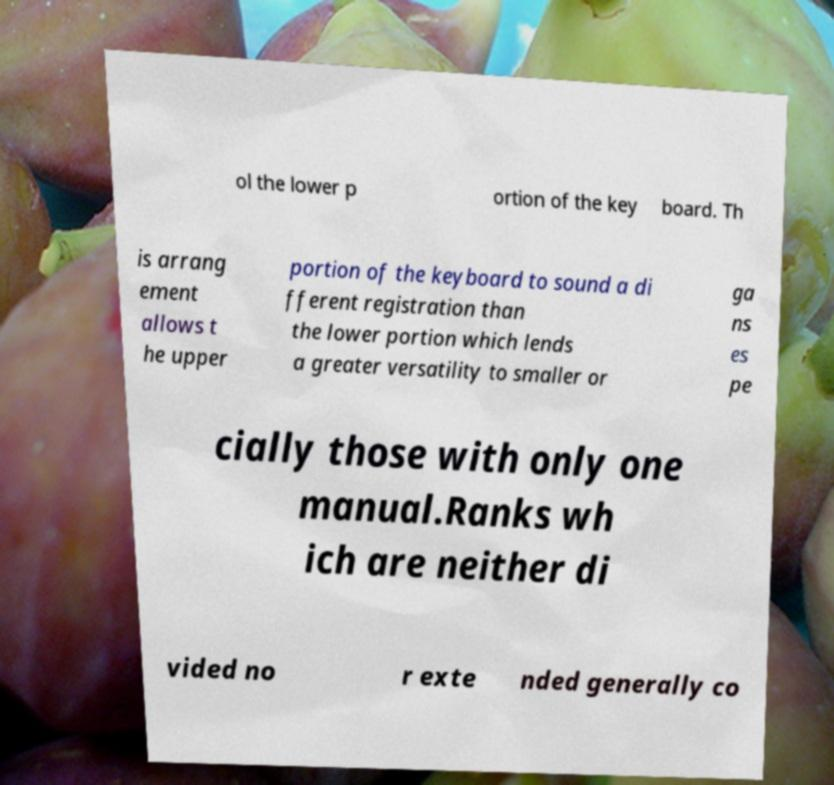Please read and relay the text visible in this image. What does it say? ol the lower p ortion of the key board. Th is arrang ement allows t he upper portion of the keyboard to sound a di fferent registration than the lower portion which lends a greater versatility to smaller or ga ns es pe cially those with only one manual.Ranks wh ich are neither di vided no r exte nded generally co 